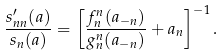<formula> <loc_0><loc_0><loc_500><loc_500>\frac { s ^ { \prime } _ { n n } ( a ) } { s _ { n } ( a ) } = \left [ \frac { f _ { n } ^ { n } ( a _ { - n } ) } { g _ { n } ^ { n } ( a _ { - n } ) } + a _ { n } \right ] ^ { - 1 } .</formula> 